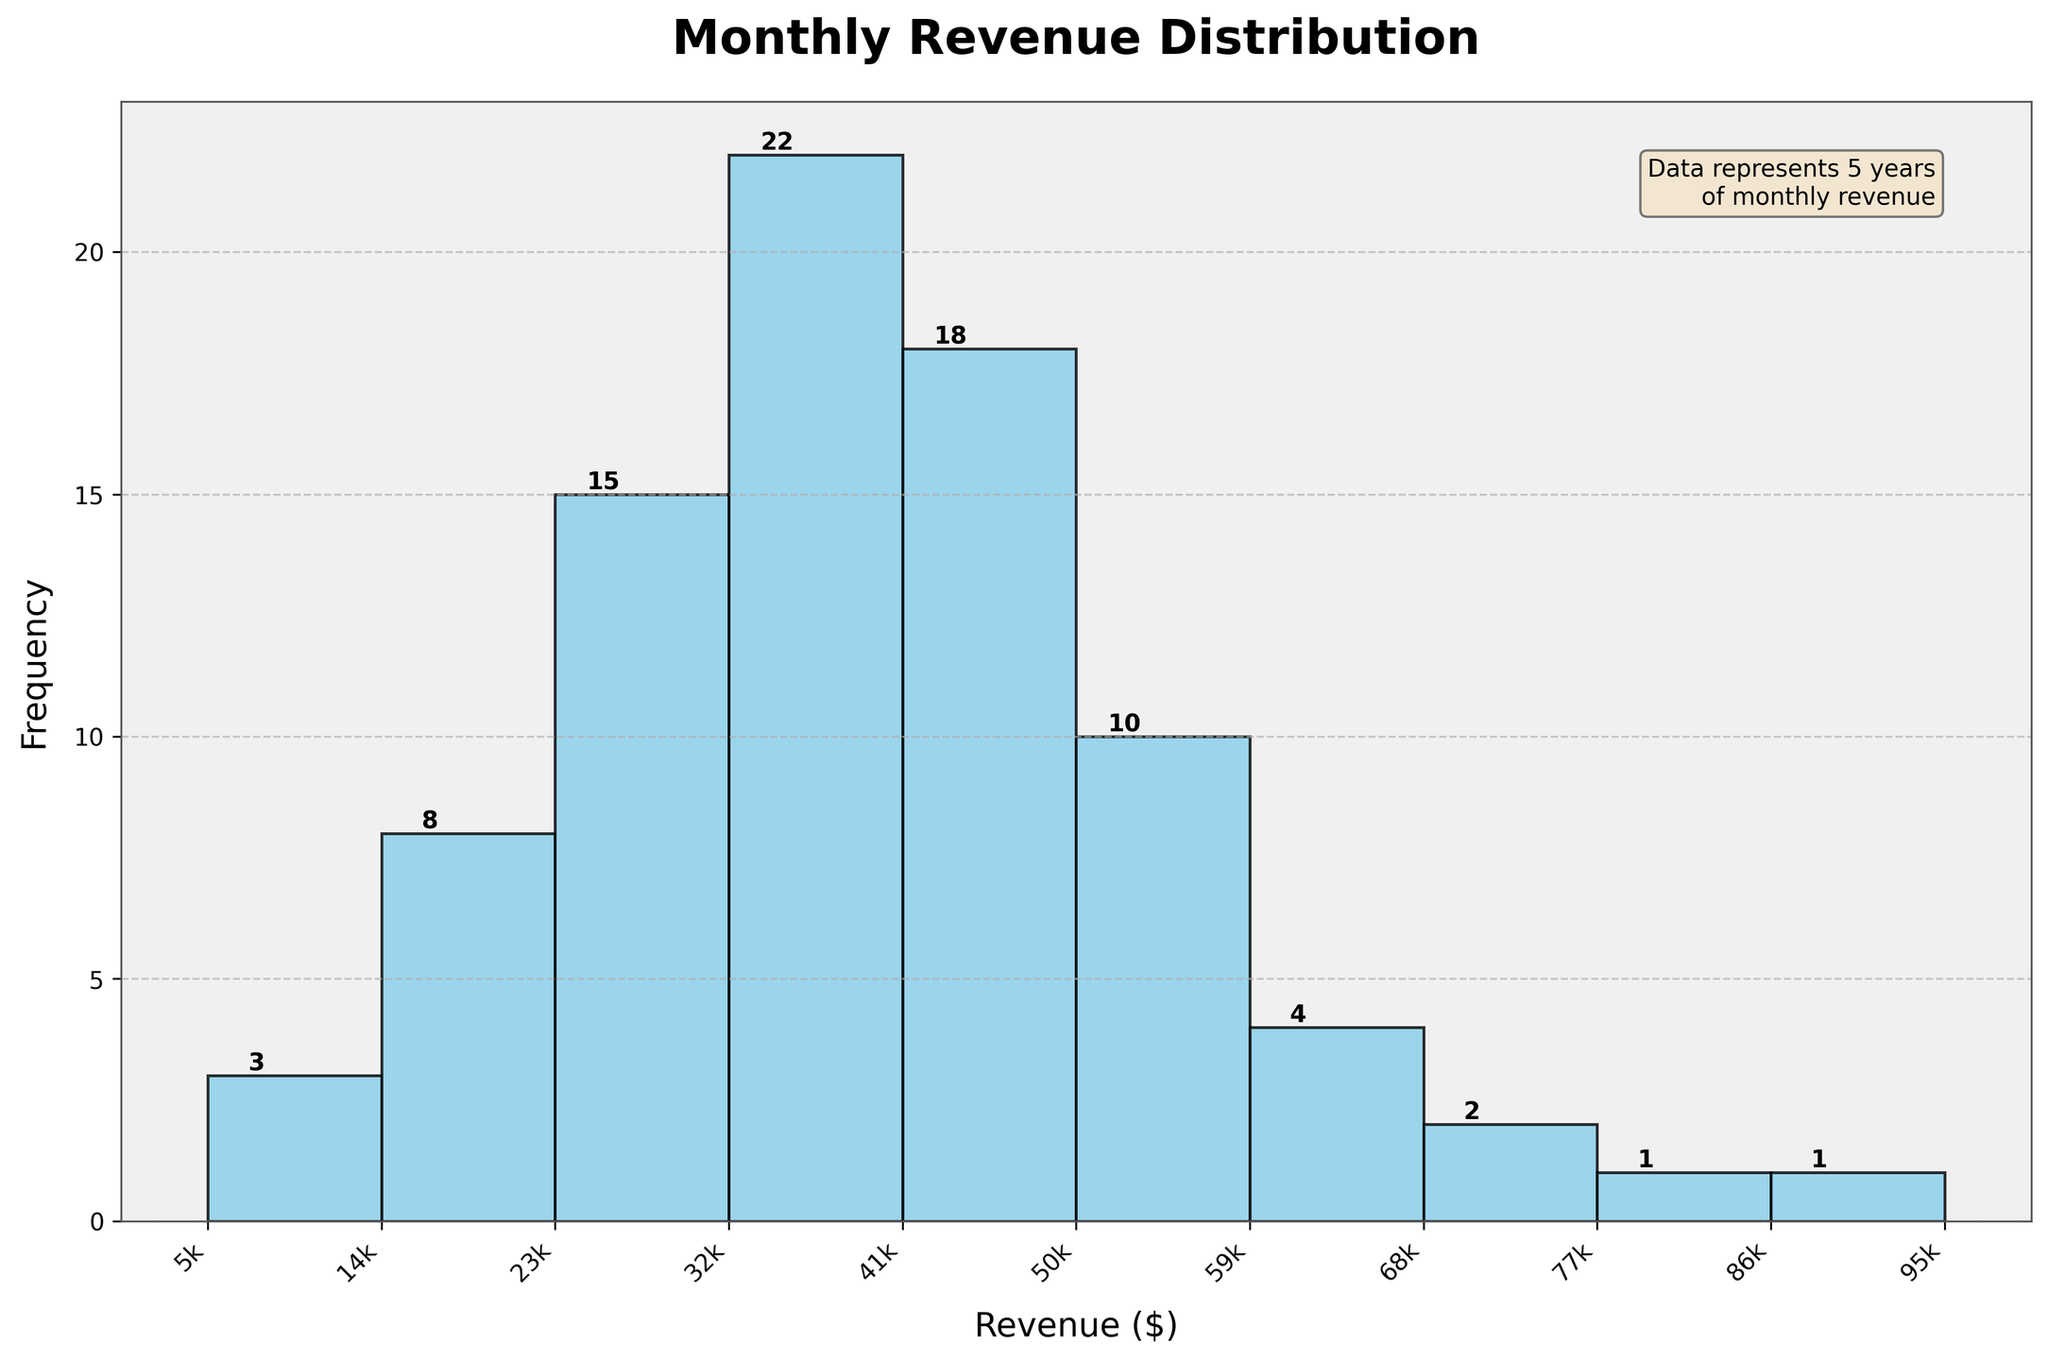What is the title of the histogram? The title of the histogram is displayed at the top of the figure with bold font.
Answer: Monthly Revenue Distribution How many bars are shown in the histogram? By counting the number of visible bars in the histogram.
Answer: 10 What revenue range has the highest frequency of monthly revenue? Locate the tallest bar in the histogram and read the corresponding revenue range on the x-axis.
Answer: 30001-40000 What is the total frequency of monthly revenues below $30,000? Sum the frequencies of the bars up to the revenue range 0-30000: 3 + 8 + 15 = 26.
Answer: 26 Which revenue range has the lowest frequency of monthly revenue? Identify the shortest bar in the histogram and read the corresponding revenue range on the x-axis.
Answer: 90001-100000 What is the cumulative frequency of monthly revenues above $60,000? Sum the frequencies of the bars from the revenue range 60001-70000 and above: 4 + 2 + 1 + 1 = 8.
Answer: 8 How many months had a revenue between $40,001 and $60,000? Sum the frequencies of the corresponding bars: 18 + 10 = 28.
Answer: 28 What is the color of the bars in the histogram? Observe the color filling of the bars in the histogram.
Answer: Sky blue How many months had a revenue of at least $70,000? Add the frequencies of the bars for revenue ranges starting from 70001-80000 and above: 2 + 1 + 1 = 4.
Answer: 4 What is the approximate midpoint revenue for the range with the highest frequency? Identify the range with the highest frequency (30001-40000) and calculate its midpoint: (30001 + 40000) / 2.
Answer: 35,000 